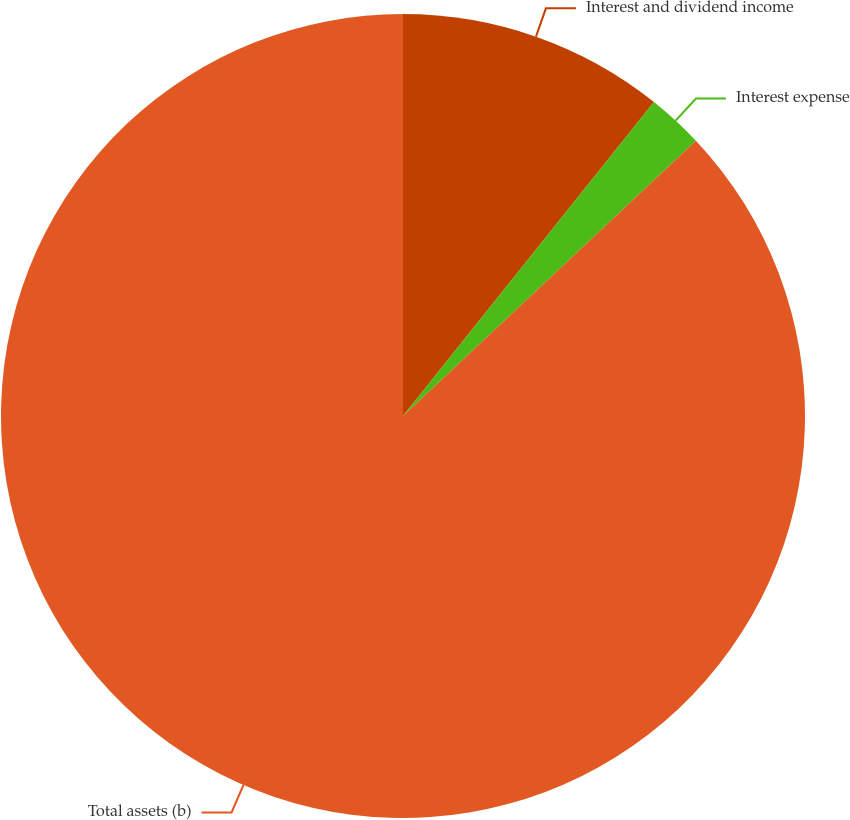<chart> <loc_0><loc_0><loc_500><loc_500><pie_chart><fcel>Interest and dividend income<fcel>Interest expense<fcel>Total assets (b)<nl><fcel>10.73%<fcel>2.26%<fcel>87.0%<nl></chart> 